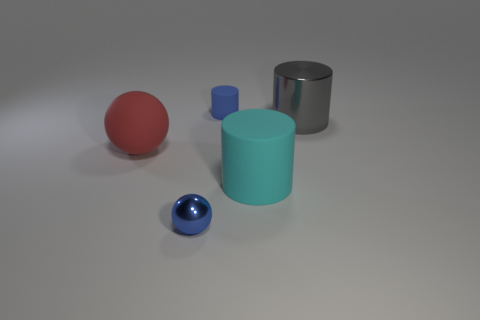Subtract all green cylinders. Subtract all gray blocks. How many cylinders are left? 3 Add 1 cyan cylinders. How many objects exist? 6 Subtract all balls. How many objects are left? 3 Add 2 spheres. How many spheres exist? 4 Subtract 0 purple cylinders. How many objects are left? 5 Subtract all small cylinders. Subtract all big yellow spheres. How many objects are left? 4 Add 1 red rubber spheres. How many red rubber spheres are left? 2 